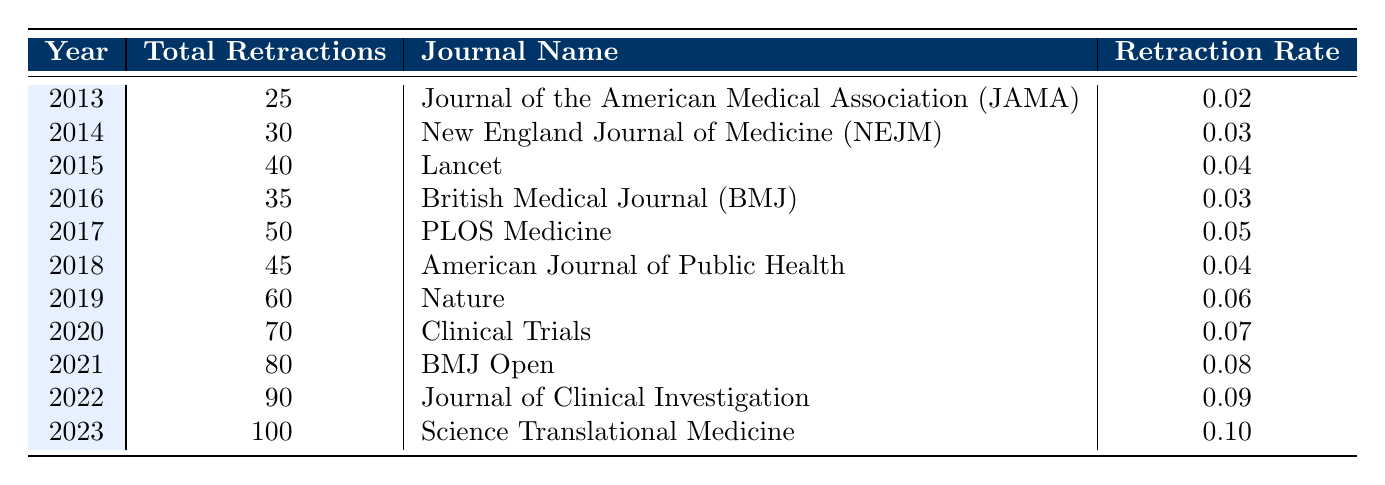What was the total number of retractions in 2015? Looking at the row for the year 2015, the table shows that the total retractions were 40.
Answer: 40 Which journal had the highest retraction rate in 2021? In 2021, the journal with the highest retraction rate, according to the table, is BMJ Open with a rate of 0.08.
Answer: BMJ Open What is the average retraction rate from 2019 to 2023? To find the average retraction rate from 2019 to 2023, we sum the rates for those years: 0.06 (2019) + 0.07 (2020) + 0.08 (2021) + 0.09 (2022) + 0.10 (2023) = 0.40. There are 5 data points, so the average is 0.40 / 5 = 0.08.
Answer: 0.08 Did the total number of retractions increase every year from 2013 to 2023? Examining the total retractions for each year, we notice a consistent increase from 25 to 100 without any decreases in any given year. Therefore, the answer is yes.
Answer: Yes What is the difference in total retractions between 2012 and 2020? Since there are no retractions listed for 2012, we only consider the 2020 figure, which is 70. Thus, the difference would be 70 - 0 = 70.
Answer: 70 How many total retractions occurred in the year with the highest recorded values? The year with the highest recorded total retractions is 2023, with 100 total retractions.
Answer: 100 What was the total number of retractions in 2016 compared to 2014? The total number of retractions in 2016 is 35, and in 2014 is 30. Thus, the comparison shows that 35 - 30 = 5 retractions more in 2016 than in 2014.
Answer: 5 Which journal had the lowest number of total retractions and what was the count? Referring to the table, the journal with the lowest total retractions is the Journal of the American Medical Association (JAMA) in 2013 with a count of 25.
Answer: 25 